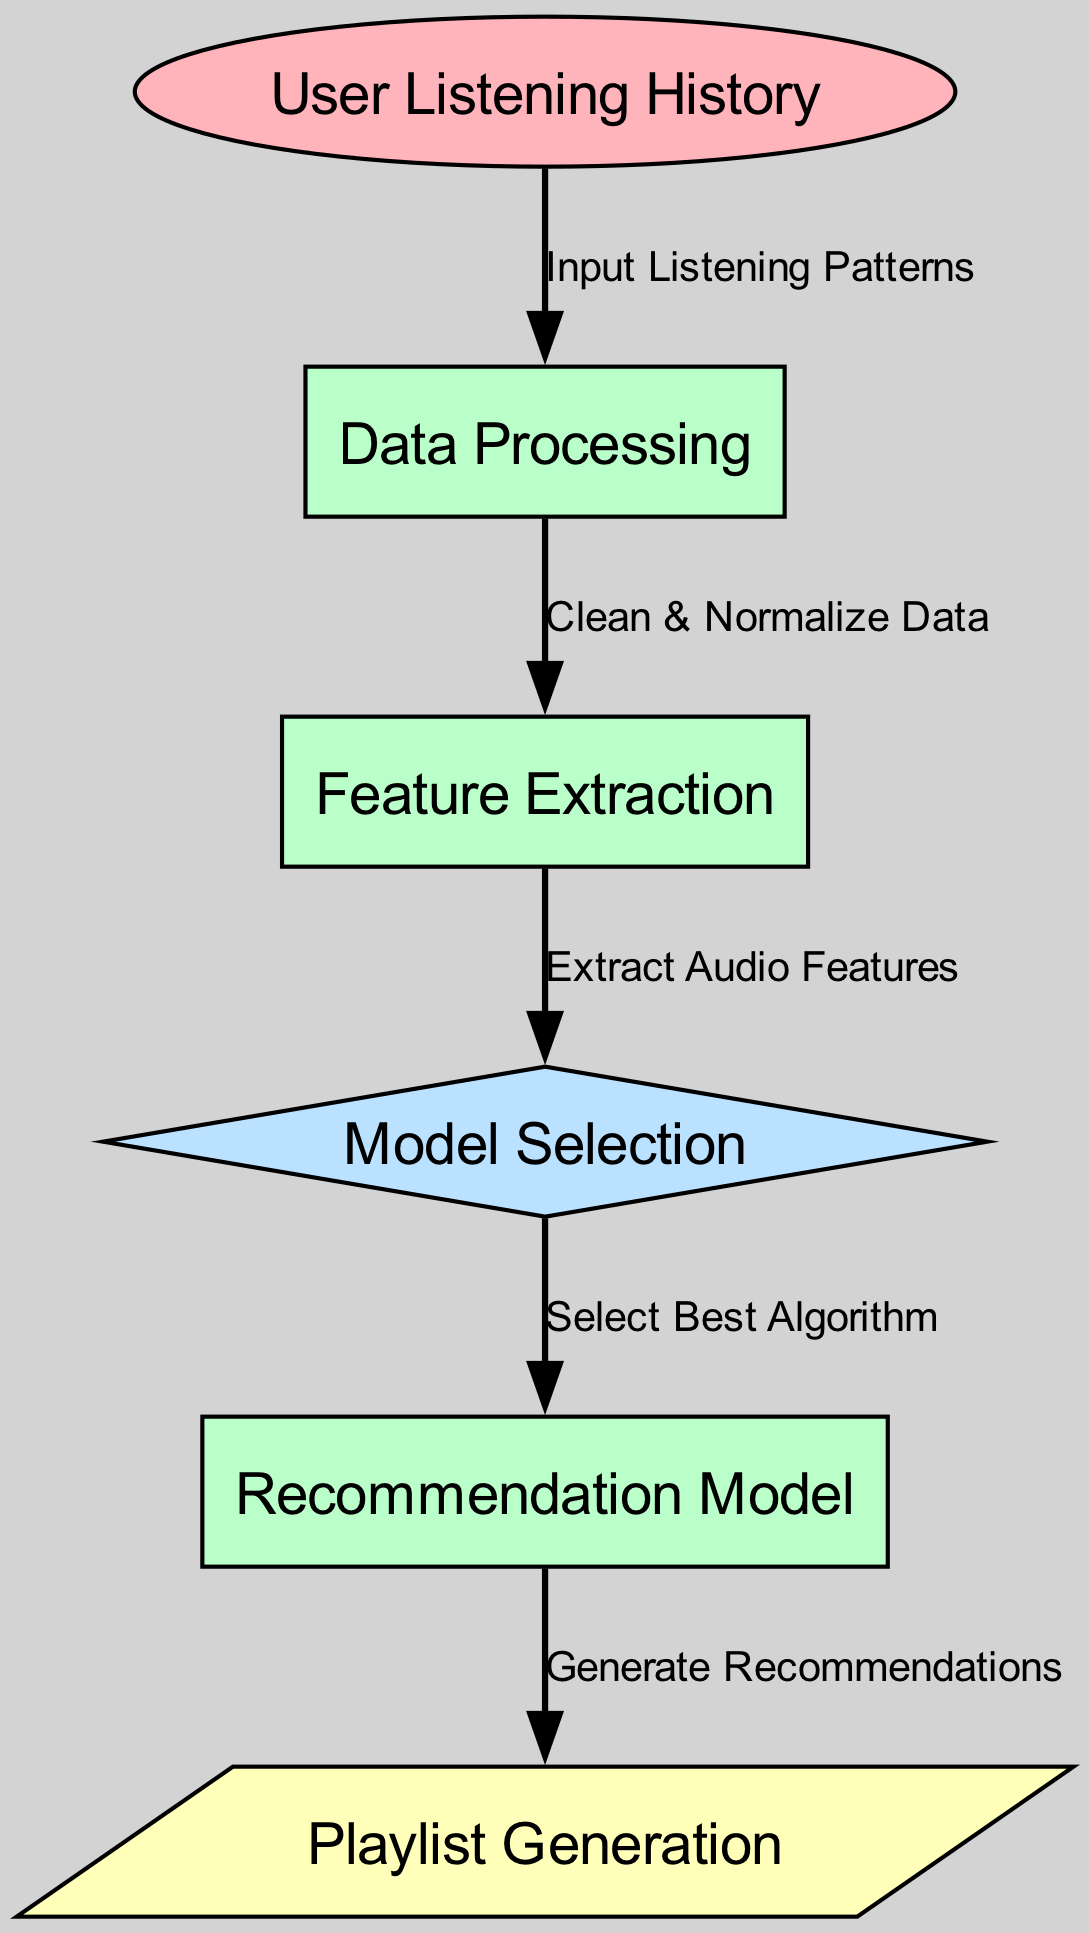What is the first node in the diagram? The diagram flows from the first node to others, and the first node listed is "User Listening History".
Answer: User Listening History How many processes are there in the diagram? Upon counting the nodes categorized as processes, there are three: "Data Processing," "Feature Extraction," and "Recommendation Model."
Answer: 3 What type of node is "Model Selection"? "Model Selection" is indicated as a decision node in the diagram based on its classification.
Answer: Decision Which edge represents the action of cleaning and normalizing data? The edge labeled "Clean & Normalize Data" connects "Data Processing" to "Feature Extraction," indicating this action.
Answer: Clean & Normalize Data What is the output of the system? The flow leads to the last node, which is "Playlist Generation" marked as the output of the entire system process.
Answer: Playlist Generation Which node follows "Feature Extraction"? Looking at the flow of arrows, "Model Selection" directly follows "Feature Extraction."
Answer: Model Selection What action happens after selecting the best algorithm? After "Model Selection," the flow leads to "Recommendation Model," which generates predictions based on the selected algorithm.
Answer: Recommendation Model How many edges are in the diagram? Counting each connection between nodes, there are five edges illustrated in the diagram.
Answer: 5 What is the main purpose of the "Recommendation Model"? The purpose of the "Recommendation Model" is to generate recommendations based on the extracted features and selected algorithm.
Answer: Generate Recommendations 